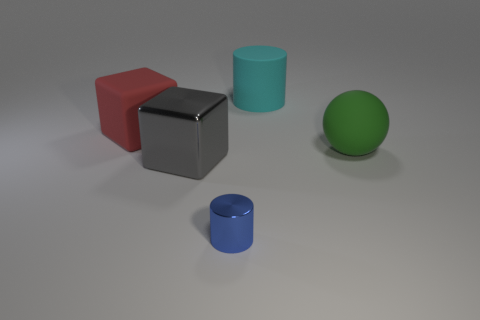Add 1 gray objects. How many objects exist? 6 Add 2 large matte cylinders. How many large matte cylinders are left? 3 Add 2 matte cubes. How many matte cubes exist? 3 Subtract 0 green cylinders. How many objects are left? 5 Subtract all blocks. How many objects are left? 3 Subtract all purple cylinders. Subtract all brown blocks. How many cylinders are left? 2 Subtract all cyan metallic balls. Subtract all red objects. How many objects are left? 4 